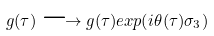Convert formula to latex. <formula><loc_0><loc_0><loc_500><loc_500>g ( \tau ) \longrightarrow g ( \tau ) e x p ( i \theta ( \tau ) \sigma _ { 3 } )</formula> 